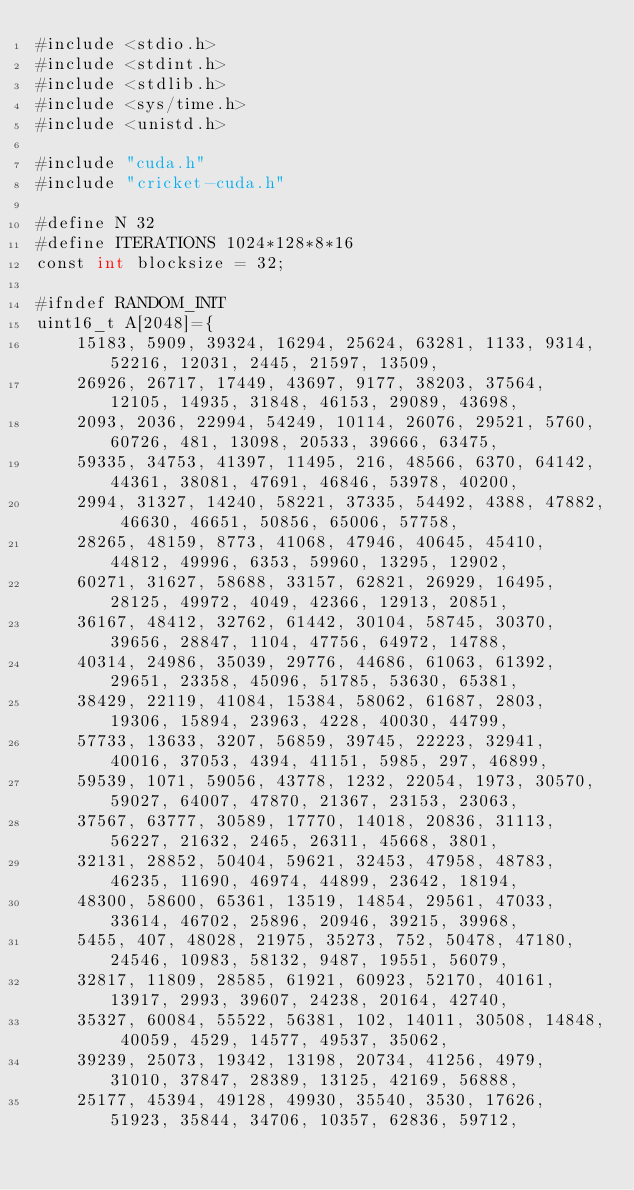Convert code to text. <code><loc_0><loc_0><loc_500><loc_500><_Cuda_>#include <stdio.h>
#include <stdint.h>
#include <stdlib.h>
#include <sys/time.h>
#include <unistd.h>

#include "cuda.h"
#include "cricket-cuda.h"

#define N 32
#define ITERATIONS 1024*128*8*16
const int blocksize = 32;

#ifndef RANDOM_INIT
uint16_t A[2048]={
    15183, 5909, 39324, 16294, 25624, 63281, 1133, 9314, 52216, 12031, 2445, 21597, 13509,
    26926, 26717, 17449, 43697, 9177, 38203, 37564, 12105, 14935, 31848, 46153, 29089, 43698,
    2093, 2036, 22994, 54249, 10114, 26076, 29521, 5760, 60726, 481, 13098, 20533, 39666, 63475,
    59335, 34753, 41397, 11495, 216, 48566, 6370, 64142, 44361, 38081, 47691, 46846, 53978, 40200,
    2994, 31327, 14240, 58221, 37335, 54492, 4388, 47882, 46630, 46651, 50856, 65006, 57758,
    28265, 48159, 8773, 41068, 47946, 40645, 45410, 44812, 49996, 6353, 59960, 13295, 12902,
    60271, 31627, 58688, 33157, 62821, 26929, 16495, 28125, 49972, 4049, 42366, 12913, 20851,
    36167, 48412, 32762, 61442, 30104, 58745, 30370, 39656, 28847, 1104, 47756, 64972, 14788,
    40314, 24986, 35039, 29776, 44686, 61063, 61392, 29651, 23358, 45096, 51785, 53630, 65381,
    38429, 22119, 41084, 15384, 58062, 61687, 2803, 19306, 15894, 23963, 4228, 40030, 44799,
    57733, 13633, 3207, 56859, 39745, 22223, 32941, 40016, 37053, 4394, 41151, 5985, 297, 46899,
    59539, 1071, 59056, 43778, 1232, 22054, 1973, 30570, 59027, 64007, 47870, 21367, 23153, 23063,
    37567, 63777, 30589, 17770, 14018, 20836, 31113, 56227, 21632, 2465, 26311, 45668, 3801,
    32131, 28852, 50404, 59621, 32453, 47958, 48783, 46235, 11690, 46974, 44899, 23642, 18194,
    48300, 58600, 65361, 13519, 14854, 29561, 47033, 33614, 46702, 25896, 20946, 39215, 39968,
    5455, 407, 48028, 21975, 35273, 752, 50478, 47180, 24546, 10983, 58132, 9487, 19551, 56079,
    32817, 11809, 28585, 61921, 60923, 52170, 40161, 13917, 2993, 39607, 24238, 20164, 42740,
    35327, 60084, 55522, 56381, 102, 14011, 30508, 14848, 40059, 4529, 14577, 49537, 35062,
    39239, 25073, 19342, 13198, 20734, 41256, 4979, 31010, 37847, 28389, 13125, 42169, 56888,
    25177, 45394, 49128, 49930, 35540, 3530, 17626, 51923, 35844, 34706, 10357, 62836, 59712,</code> 